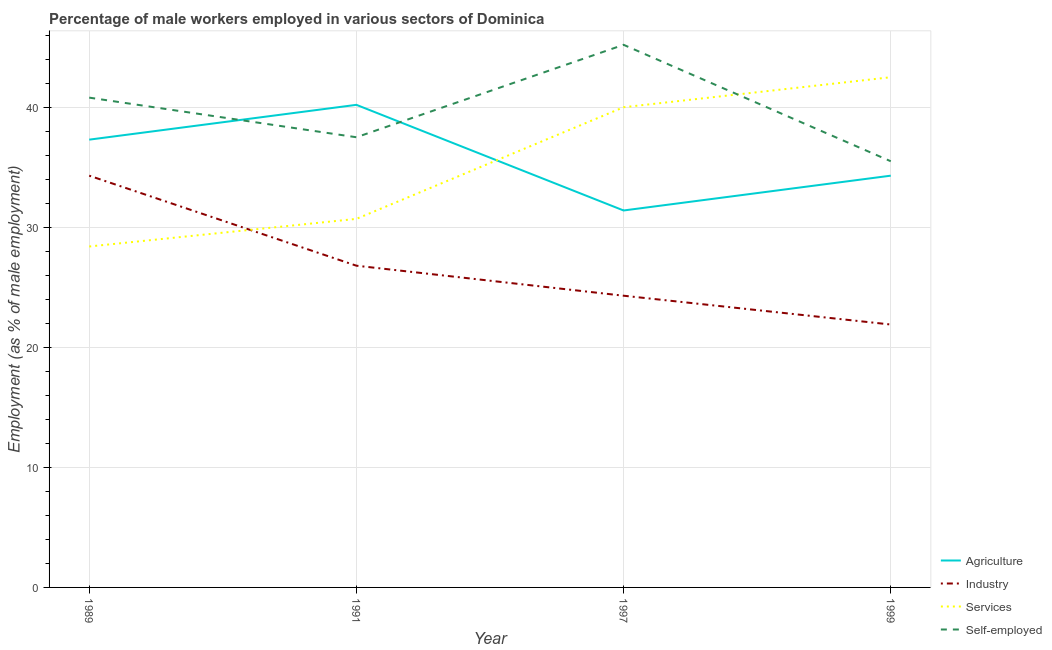What is the percentage of male workers in industry in 1997?
Your answer should be very brief. 24.3. Across all years, what is the maximum percentage of male workers in services?
Your answer should be compact. 42.5. Across all years, what is the minimum percentage of self employed male workers?
Give a very brief answer. 35.5. In which year was the percentage of male workers in agriculture maximum?
Provide a succinct answer. 1991. What is the total percentage of male workers in industry in the graph?
Give a very brief answer. 107.3. What is the difference between the percentage of male workers in services in 1991 and that in 1997?
Your response must be concise. -9.3. What is the difference between the percentage of male workers in services in 1989 and the percentage of self employed male workers in 1999?
Keep it short and to the point. -7.1. What is the average percentage of male workers in agriculture per year?
Keep it short and to the point. 35.8. In the year 1997, what is the difference between the percentage of male workers in industry and percentage of male workers in agriculture?
Your response must be concise. -7.1. In how many years, is the percentage of male workers in industry greater than 24 %?
Offer a very short reply. 3. What is the ratio of the percentage of male workers in agriculture in 1989 to that in 1999?
Your answer should be very brief. 1.09. What is the difference between the highest and the second highest percentage of male workers in agriculture?
Provide a short and direct response. 2.9. What is the difference between the highest and the lowest percentage of male workers in services?
Keep it short and to the point. 14.1. In how many years, is the percentage of male workers in services greater than the average percentage of male workers in services taken over all years?
Offer a terse response. 2. Is the sum of the percentage of male workers in services in 1991 and 1999 greater than the maximum percentage of male workers in agriculture across all years?
Offer a terse response. Yes. Is it the case that in every year, the sum of the percentage of self employed male workers and percentage of male workers in agriculture is greater than the sum of percentage of male workers in services and percentage of male workers in industry?
Ensure brevity in your answer.  Yes. Is it the case that in every year, the sum of the percentage of male workers in agriculture and percentage of male workers in industry is greater than the percentage of male workers in services?
Ensure brevity in your answer.  Yes. Does the percentage of male workers in agriculture monotonically increase over the years?
Provide a succinct answer. No. Is the percentage of male workers in agriculture strictly greater than the percentage of self employed male workers over the years?
Your answer should be compact. No. How many lines are there?
Your answer should be compact. 4. Are the values on the major ticks of Y-axis written in scientific E-notation?
Your response must be concise. No. How many legend labels are there?
Give a very brief answer. 4. What is the title of the graph?
Your answer should be very brief. Percentage of male workers employed in various sectors of Dominica. Does "Denmark" appear as one of the legend labels in the graph?
Your response must be concise. No. What is the label or title of the X-axis?
Make the answer very short. Year. What is the label or title of the Y-axis?
Your answer should be compact. Employment (as % of male employment). What is the Employment (as % of male employment) of Agriculture in 1989?
Provide a short and direct response. 37.3. What is the Employment (as % of male employment) in Industry in 1989?
Provide a short and direct response. 34.3. What is the Employment (as % of male employment) of Services in 1989?
Keep it short and to the point. 28.4. What is the Employment (as % of male employment) in Self-employed in 1989?
Provide a short and direct response. 40.8. What is the Employment (as % of male employment) in Agriculture in 1991?
Provide a succinct answer. 40.2. What is the Employment (as % of male employment) in Industry in 1991?
Provide a short and direct response. 26.8. What is the Employment (as % of male employment) of Services in 1991?
Your answer should be very brief. 30.7. What is the Employment (as % of male employment) of Self-employed in 1991?
Offer a very short reply. 37.5. What is the Employment (as % of male employment) of Agriculture in 1997?
Offer a terse response. 31.4. What is the Employment (as % of male employment) of Industry in 1997?
Your answer should be compact. 24.3. What is the Employment (as % of male employment) of Services in 1997?
Offer a terse response. 40. What is the Employment (as % of male employment) of Self-employed in 1997?
Your answer should be very brief. 45.2. What is the Employment (as % of male employment) of Agriculture in 1999?
Your response must be concise. 34.3. What is the Employment (as % of male employment) of Industry in 1999?
Your answer should be very brief. 21.9. What is the Employment (as % of male employment) in Services in 1999?
Offer a terse response. 42.5. What is the Employment (as % of male employment) of Self-employed in 1999?
Your answer should be compact. 35.5. Across all years, what is the maximum Employment (as % of male employment) of Agriculture?
Offer a terse response. 40.2. Across all years, what is the maximum Employment (as % of male employment) of Industry?
Ensure brevity in your answer.  34.3. Across all years, what is the maximum Employment (as % of male employment) in Services?
Provide a succinct answer. 42.5. Across all years, what is the maximum Employment (as % of male employment) of Self-employed?
Offer a terse response. 45.2. Across all years, what is the minimum Employment (as % of male employment) in Agriculture?
Keep it short and to the point. 31.4. Across all years, what is the minimum Employment (as % of male employment) of Industry?
Ensure brevity in your answer.  21.9. Across all years, what is the minimum Employment (as % of male employment) in Services?
Offer a very short reply. 28.4. Across all years, what is the minimum Employment (as % of male employment) in Self-employed?
Offer a very short reply. 35.5. What is the total Employment (as % of male employment) of Agriculture in the graph?
Ensure brevity in your answer.  143.2. What is the total Employment (as % of male employment) of Industry in the graph?
Keep it short and to the point. 107.3. What is the total Employment (as % of male employment) of Services in the graph?
Your response must be concise. 141.6. What is the total Employment (as % of male employment) of Self-employed in the graph?
Your answer should be compact. 159. What is the difference between the Employment (as % of male employment) of Industry in 1989 and that in 1991?
Provide a succinct answer. 7.5. What is the difference between the Employment (as % of male employment) of Self-employed in 1989 and that in 1991?
Offer a very short reply. 3.3. What is the difference between the Employment (as % of male employment) in Industry in 1989 and that in 1997?
Provide a short and direct response. 10. What is the difference between the Employment (as % of male employment) of Services in 1989 and that in 1997?
Provide a succinct answer. -11.6. What is the difference between the Employment (as % of male employment) in Self-employed in 1989 and that in 1997?
Your answer should be compact. -4.4. What is the difference between the Employment (as % of male employment) in Industry in 1989 and that in 1999?
Provide a short and direct response. 12.4. What is the difference between the Employment (as % of male employment) in Services in 1989 and that in 1999?
Ensure brevity in your answer.  -14.1. What is the difference between the Employment (as % of male employment) of Self-employed in 1989 and that in 1999?
Provide a short and direct response. 5.3. What is the difference between the Employment (as % of male employment) in Industry in 1991 and that in 1997?
Your answer should be very brief. 2.5. What is the difference between the Employment (as % of male employment) in Services in 1991 and that in 1997?
Make the answer very short. -9.3. What is the difference between the Employment (as % of male employment) in Agriculture in 1991 and that in 1999?
Ensure brevity in your answer.  5.9. What is the difference between the Employment (as % of male employment) of Industry in 1991 and that in 1999?
Your answer should be very brief. 4.9. What is the difference between the Employment (as % of male employment) of Services in 1991 and that in 1999?
Ensure brevity in your answer.  -11.8. What is the difference between the Employment (as % of male employment) of Self-employed in 1991 and that in 1999?
Keep it short and to the point. 2. What is the difference between the Employment (as % of male employment) of Agriculture in 1997 and that in 1999?
Keep it short and to the point. -2.9. What is the difference between the Employment (as % of male employment) of Self-employed in 1997 and that in 1999?
Give a very brief answer. 9.7. What is the difference between the Employment (as % of male employment) in Agriculture in 1989 and the Employment (as % of male employment) in Services in 1991?
Your answer should be compact. 6.6. What is the difference between the Employment (as % of male employment) in Agriculture in 1989 and the Employment (as % of male employment) in Self-employed in 1991?
Give a very brief answer. -0.2. What is the difference between the Employment (as % of male employment) in Industry in 1989 and the Employment (as % of male employment) in Self-employed in 1991?
Offer a terse response. -3.2. What is the difference between the Employment (as % of male employment) of Services in 1989 and the Employment (as % of male employment) of Self-employed in 1991?
Offer a very short reply. -9.1. What is the difference between the Employment (as % of male employment) in Industry in 1989 and the Employment (as % of male employment) in Self-employed in 1997?
Offer a terse response. -10.9. What is the difference between the Employment (as % of male employment) in Services in 1989 and the Employment (as % of male employment) in Self-employed in 1997?
Keep it short and to the point. -16.8. What is the difference between the Employment (as % of male employment) in Industry in 1989 and the Employment (as % of male employment) in Self-employed in 1999?
Keep it short and to the point. -1.2. What is the difference between the Employment (as % of male employment) of Services in 1989 and the Employment (as % of male employment) of Self-employed in 1999?
Your response must be concise. -7.1. What is the difference between the Employment (as % of male employment) of Industry in 1991 and the Employment (as % of male employment) of Services in 1997?
Provide a short and direct response. -13.2. What is the difference between the Employment (as % of male employment) of Industry in 1991 and the Employment (as % of male employment) of Self-employed in 1997?
Provide a succinct answer. -18.4. What is the difference between the Employment (as % of male employment) of Agriculture in 1991 and the Employment (as % of male employment) of Industry in 1999?
Keep it short and to the point. 18.3. What is the difference between the Employment (as % of male employment) in Agriculture in 1991 and the Employment (as % of male employment) in Self-employed in 1999?
Provide a short and direct response. 4.7. What is the difference between the Employment (as % of male employment) in Industry in 1991 and the Employment (as % of male employment) in Services in 1999?
Provide a short and direct response. -15.7. What is the difference between the Employment (as % of male employment) of Industry in 1991 and the Employment (as % of male employment) of Self-employed in 1999?
Provide a succinct answer. -8.7. What is the difference between the Employment (as % of male employment) in Agriculture in 1997 and the Employment (as % of male employment) in Services in 1999?
Your response must be concise. -11.1. What is the difference between the Employment (as % of male employment) in Agriculture in 1997 and the Employment (as % of male employment) in Self-employed in 1999?
Keep it short and to the point. -4.1. What is the difference between the Employment (as % of male employment) in Industry in 1997 and the Employment (as % of male employment) in Services in 1999?
Your response must be concise. -18.2. What is the difference between the Employment (as % of male employment) in Services in 1997 and the Employment (as % of male employment) in Self-employed in 1999?
Give a very brief answer. 4.5. What is the average Employment (as % of male employment) in Agriculture per year?
Ensure brevity in your answer.  35.8. What is the average Employment (as % of male employment) in Industry per year?
Your answer should be very brief. 26.82. What is the average Employment (as % of male employment) in Services per year?
Ensure brevity in your answer.  35.4. What is the average Employment (as % of male employment) in Self-employed per year?
Keep it short and to the point. 39.75. In the year 1989, what is the difference between the Employment (as % of male employment) of Agriculture and Employment (as % of male employment) of Industry?
Provide a short and direct response. 3. In the year 1989, what is the difference between the Employment (as % of male employment) of Agriculture and Employment (as % of male employment) of Services?
Provide a succinct answer. 8.9. In the year 1989, what is the difference between the Employment (as % of male employment) of Industry and Employment (as % of male employment) of Services?
Offer a terse response. 5.9. In the year 1989, what is the difference between the Employment (as % of male employment) in Industry and Employment (as % of male employment) in Self-employed?
Your answer should be compact. -6.5. In the year 1989, what is the difference between the Employment (as % of male employment) in Services and Employment (as % of male employment) in Self-employed?
Keep it short and to the point. -12.4. In the year 1991, what is the difference between the Employment (as % of male employment) in Agriculture and Employment (as % of male employment) in Industry?
Your response must be concise. 13.4. In the year 1991, what is the difference between the Employment (as % of male employment) of Agriculture and Employment (as % of male employment) of Self-employed?
Keep it short and to the point. 2.7. In the year 1991, what is the difference between the Employment (as % of male employment) of Industry and Employment (as % of male employment) of Services?
Offer a very short reply. -3.9. In the year 1991, what is the difference between the Employment (as % of male employment) of Services and Employment (as % of male employment) of Self-employed?
Your response must be concise. -6.8. In the year 1997, what is the difference between the Employment (as % of male employment) in Agriculture and Employment (as % of male employment) in Industry?
Your response must be concise. 7.1. In the year 1997, what is the difference between the Employment (as % of male employment) in Agriculture and Employment (as % of male employment) in Self-employed?
Make the answer very short. -13.8. In the year 1997, what is the difference between the Employment (as % of male employment) in Industry and Employment (as % of male employment) in Services?
Your answer should be very brief. -15.7. In the year 1997, what is the difference between the Employment (as % of male employment) of Industry and Employment (as % of male employment) of Self-employed?
Provide a short and direct response. -20.9. In the year 1999, what is the difference between the Employment (as % of male employment) in Agriculture and Employment (as % of male employment) in Industry?
Ensure brevity in your answer.  12.4. In the year 1999, what is the difference between the Employment (as % of male employment) in Agriculture and Employment (as % of male employment) in Services?
Your answer should be very brief. -8.2. In the year 1999, what is the difference between the Employment (as % of male employment) of Agriculture and Employment (as % of male employment) of Self-employed?
Your response must be concise. -1.2. In the year 1999, what is the difference between the Employment (as % of male employment) of Industry and Employment (as % of male employment) of Services?
Make the answer very short. -20.6. In the year 1999, what is the difference between the Employment (as % of male employment) in Industry and Employment (as % of male employment) in Self-employed?
Make the answer very short. -13.6. In the year 1999, what is the difference between the Employment (as % of male employment) in Services and Employment (as % of male employment) in Self-employed?
Provide a succinct answer. 7. What is the ratio of the Employment (as % of male employment) of Agriculture in 1989 to that in 1991?
Ensure brevity in your answer.  0.93. What is the ratio of the Employment (as % of male employment) in Industry in 1989 to that in 1991?
Your answer should be very brief. 1.28. What is the ratio of the Employment (as % of male employment) of Services in 1989 to that in 1991?
Keep it short and to the point. 0.93. What is the ratio of the Employment (as % of male employment) in Self-employed in 1989 to that in 1991?
Provide a succinct answer. 1.09. What is the ratio of the Employment (as % of male employment) of Agriculture in 1989 to that in 1997?
Your answer should be very brief. 1.19. What is the ratio of the Employment (as % of male employment) in Industry in 1989 to that in 1997?
Offer a terse response. 1.41. What is the ratio of the Employment (as % of male employment) in Services in 1989 to that in 1997?
Offer a terse response. 0.71. What is the ratio of the Employment (as % of male employment) of Self-employed in 1989 to that in 1997?
Keep it short and to the point. 0.9. What is the ratio of the Employment (as % of male employment) in Agriculture in 1989 to that in 1999?
Make the answer very short. 1.09. What is the ratio of the Employment (as % of male employment) in Industry in 1989 to that in 1999?
Offer a very short reply. 1.57. What is the ratio of the Employment (as % of male employment) of Services in 1989 to that in 1999?
Provide a succinct answer. 0.67. What is the ratio of the Employment (as % of male employment) in Self-employed in 1989 to that in 1999?
Provide a short and direct response. 1.15. What is the ratio of the Employment (as % of male employment) in Agriculture in 1991 to that in 1997?
Your response must be concise. 1.28. What is the ratio of the Employment (as % of male employment) of Industry in 1991 to that in 1997?
Offer a very short reply. 1.1. What is the ratio of the Employment (as % of male employment) of Services in 1991 to that in 1997?
Your response must be concise. 0.77. What is the ratio of the Employment (as % of male employment) of Self-employed in 1991 to that in 1997?
Offer a terse response. 0.83. What is the ratio of the Employment (as % of male employment) of Agriculture in 1991 to that in 1999?
Ensure brevity in your answer.  1.17. What is the ratio of the Employment (as % of male employment) in Industry in 1991 to that in 1999?
Provide a short and direct response. 1.22. What is the ratio of the Employment (as % of male employment) in Services in 1991 to that in 1999?
Ensure brevity in your answer.  0.72. What is the ratio of the Employment (as % of male employment) in Self-employed in 1991 to that in 1999?
Offer a very short reply. 1.06. What is the ratio of the Employment (as % of male employment) in Agriculture in 1997 to that in 1999?
Make the answer very short. 0.92. What is the ratio of the Employment (as % of male employment) of Industry in 1997 to that in 1999?
Make the answer very short. 1.11. What is the ratio of the Employment (as % of male employment) of Self-employed in 1997 to that in 1999?
Keep it short and to the point. 1.27. What is the difference between the highest and the second highest Employment (as % of male employment) in Self-employed?
Ensure brevity in your answer.  4.4. 